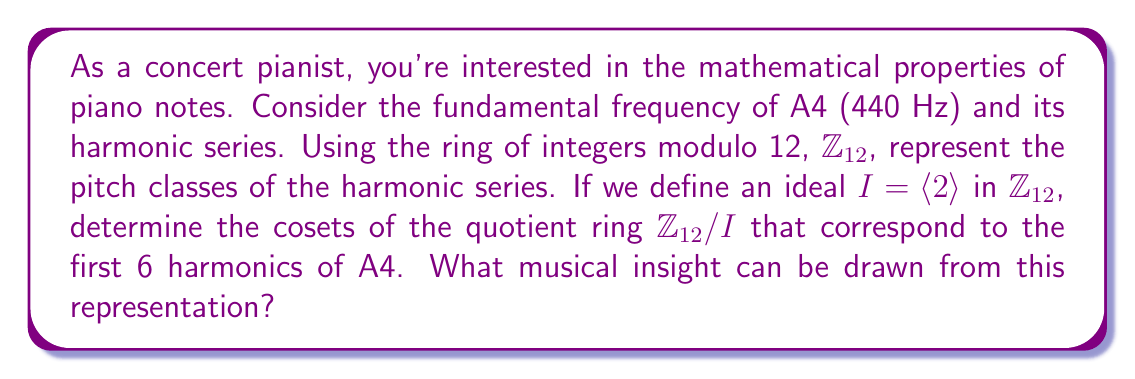Give your solution to this math problem. To solve this problem, let's follow these steps:

1) First, recall that the harmonic series of a fundamental frequency $f$ is given by the sequence $f, 2f, 3f, 4f, 5f, 6f, ...$

2) In the 12-tone equal temperament system, we can represent pitch classes as integers modulo 12, where 0 represents A, 1 represents A#/Bb, 2 represents B, and so on.

3) A4 (440 Hz) corresponds to 0 in $\mathbb{Z}_{12}$. Let's calculate the first 6 harmonics:

   1st harmonic (fundamental): 0 (A)
   2nd harmonic: 0 (A)
   3rd harmonic: 7 (E)
   4th harmonic: 0 (A)
   5th harmonic: 4 (C#)
   6th harmonic: 7 (E)

4) Now, let's consider the ideal $I = \langle 2 \rangle$ in $\mathbb{Z}_{12}$. This ideal consists of all even numbers in $\mathbb{Z}_{12}$: $I = \{0, 2, 4, 6, 8, 10\}$

5) The quotient ring $\mathbb{Z}_{12}/I$ has two cosets:
   $[0] = \{0, 2, 4, 6, 8, 10\}$ (even numbers)
   $[1] = \{1, 3, 5, 7, 9, 11\}$ (odd numbers)

6) Now, let's classify our harmonics into these cosets:

   1st harmonic (0): $[0]$
   2nd harmonic (0): $[0]$
   3rd harmonic (7): $[1]$
   4th harmonic (0): $[0]$
   5th harmonic (4): $[0]$
   6th harmonic (7): $[1]$

7) Musical insight: The cosets separate the harmonics into two groups. $[0]$ contains the 1st, 2nd, 4th, and 5th harmonics, which form a major chord (A-C#-E in this case). $[1]$ contains the 3rd and 6th harmonics, which reinforce the fifth of the chord (E).
Answer: The cosets corresponding to the first 6 harmonics are:

1st harmonic: $[0]$
2nd harmonic: $[0]$
3rd harmonic: $[1]$
4th harmonic: $[0]$
5th harmonic: $[0]$
6th harmonic: $[1]$

This representation highlights the natural division between harmonics that form the major chord (in $[0]$) and those that reinforce the fifth (in $[1]$), providing a mathematical explanation for the consonance of these intervals in Western music. 